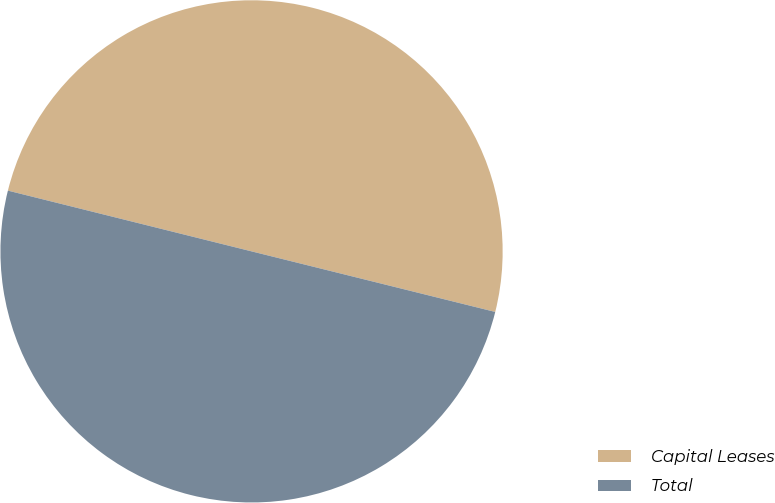<chart> <loc_0><loc_0><loc_500><loc_500><pie_chart><fcel>Capital Leases<fcel>Total<nl><fcel>49.99%<fcel>50.01%<nl></chart> 